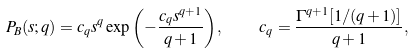Convert formula to latex. <formula><loc_0><loc_0><loc_500><loc_500>P _ { B } ( s ; q ) = c _ { q } s ^ { q } \exp { \left ( - \frac { c _ { q } s ^ { q + 1 } } { q + 1 } \right ) } , \quad c _ { q } = \frac { \Gamma ^ { q + 1 } [ 1 / ( q + 1 ) ] } { q + 1 } ,</formula> 